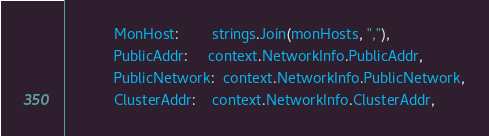<code> <loc_0><loc_0><loc_500><loc_500><_Go_>			MonHost:        strings.Join(monHosts, ","),
			PublicAddr:     context.NetworkInfo.PublicAddr,
			PublicNetwork:  context.NetworkInfo.PublicNetwork,
			ClusterAddr:    context.NetworkInfo.ClusterAddr,</code> 